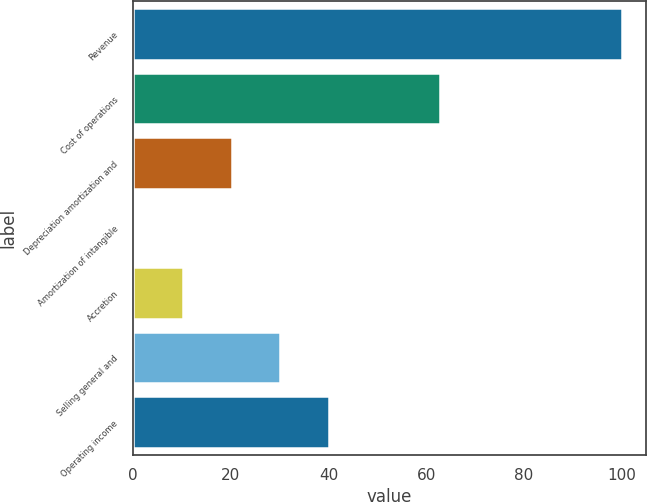<chart> <loc_0><loc_0><loc_500><loc_500><bar_chart><fcel>Revenue<fcel>Cost of operations<fcel>Depreciation amortization and<fcel>Amortization of intangible<fcel>Accretion<fcel>Selling general and<fcel>Operating income<nl><fcel>100<fcel>62.7<fcel>20.16<fcel>0.2<fcel>10.18<fcel>30.14<fcel>40.12<nl></chart> 